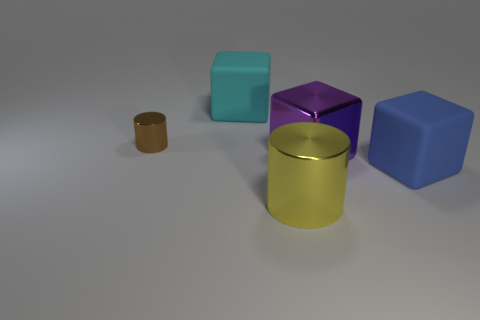The other large metal thing that is the same shape as the brown object is what color?
Your answer should be very brief. Yellow. Are there fewer purple metal objects in front of the tiny cylinder than metal blocks?
Provide a short and direct response. No. The cylinder in front of the purple block is what color?
Provide a short and direct response. Yellow. Are there any large yellow shiny objects of the same shape as the big purple object?
Your answer should be compact. No. How many yellow objects are the same shape as the cyan matte thing?
Offer a terse response. 0. Does the large cylinder have the same color as the tiny metallic cylinder?
Keep it short and to the point. No. Is the number of purple cubes less than the number of big green objects?
Give a very brief answer. No. What material is the cylinder that is behind the big blue cube?
Ensure brevity in your answer.  Metal. What is the material of the blue object that is the same size as the purple shiny block?
Your response must be concise. Rubber. There is a cylinder left of the big object in front of the rubber object right of the yellow metallic cylinder; what is its material?
Your answer should be compact. Metal. 